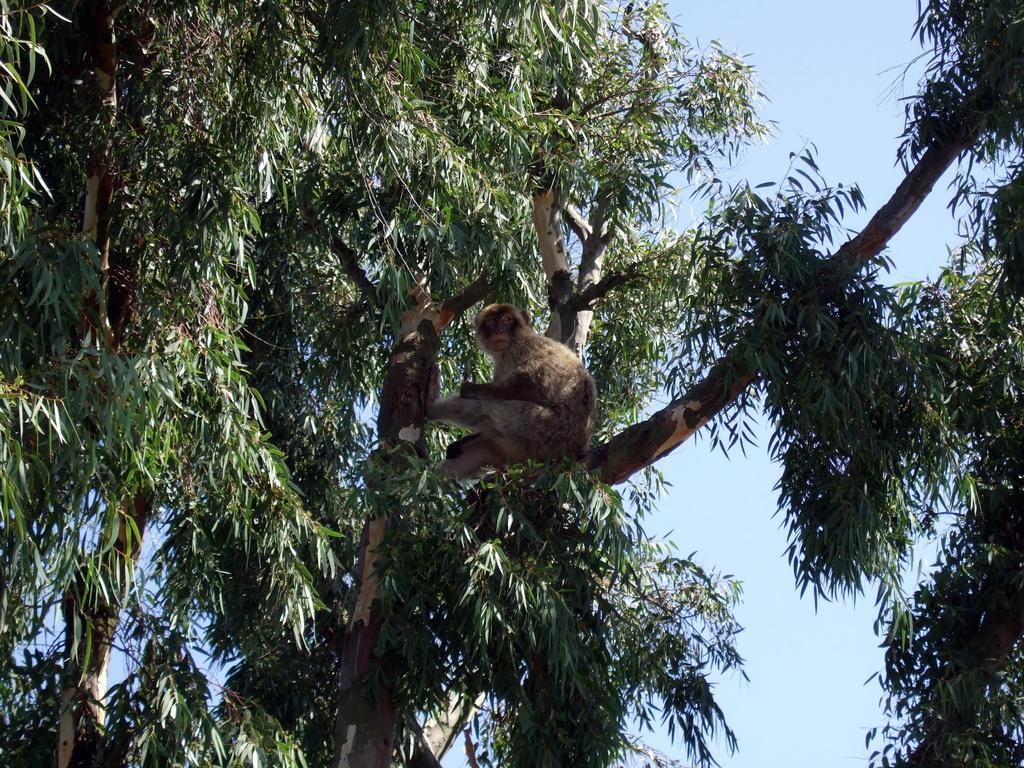What animal can be seen in the image? There is a monkey in the image. Where is the monkey located? The monkey is sitting on a branch. What type of tree is the branch from? The branch is from a tree with green leaves. What can be seen on the right side of the image? There is another tree on the right side of the image. What is the color of the sky in the background of the image? The sky is blue in the background of the image. What type of corn is growing on the monkey's head in the image? There is no corn present in the image, and the monkey's head is not shown. 